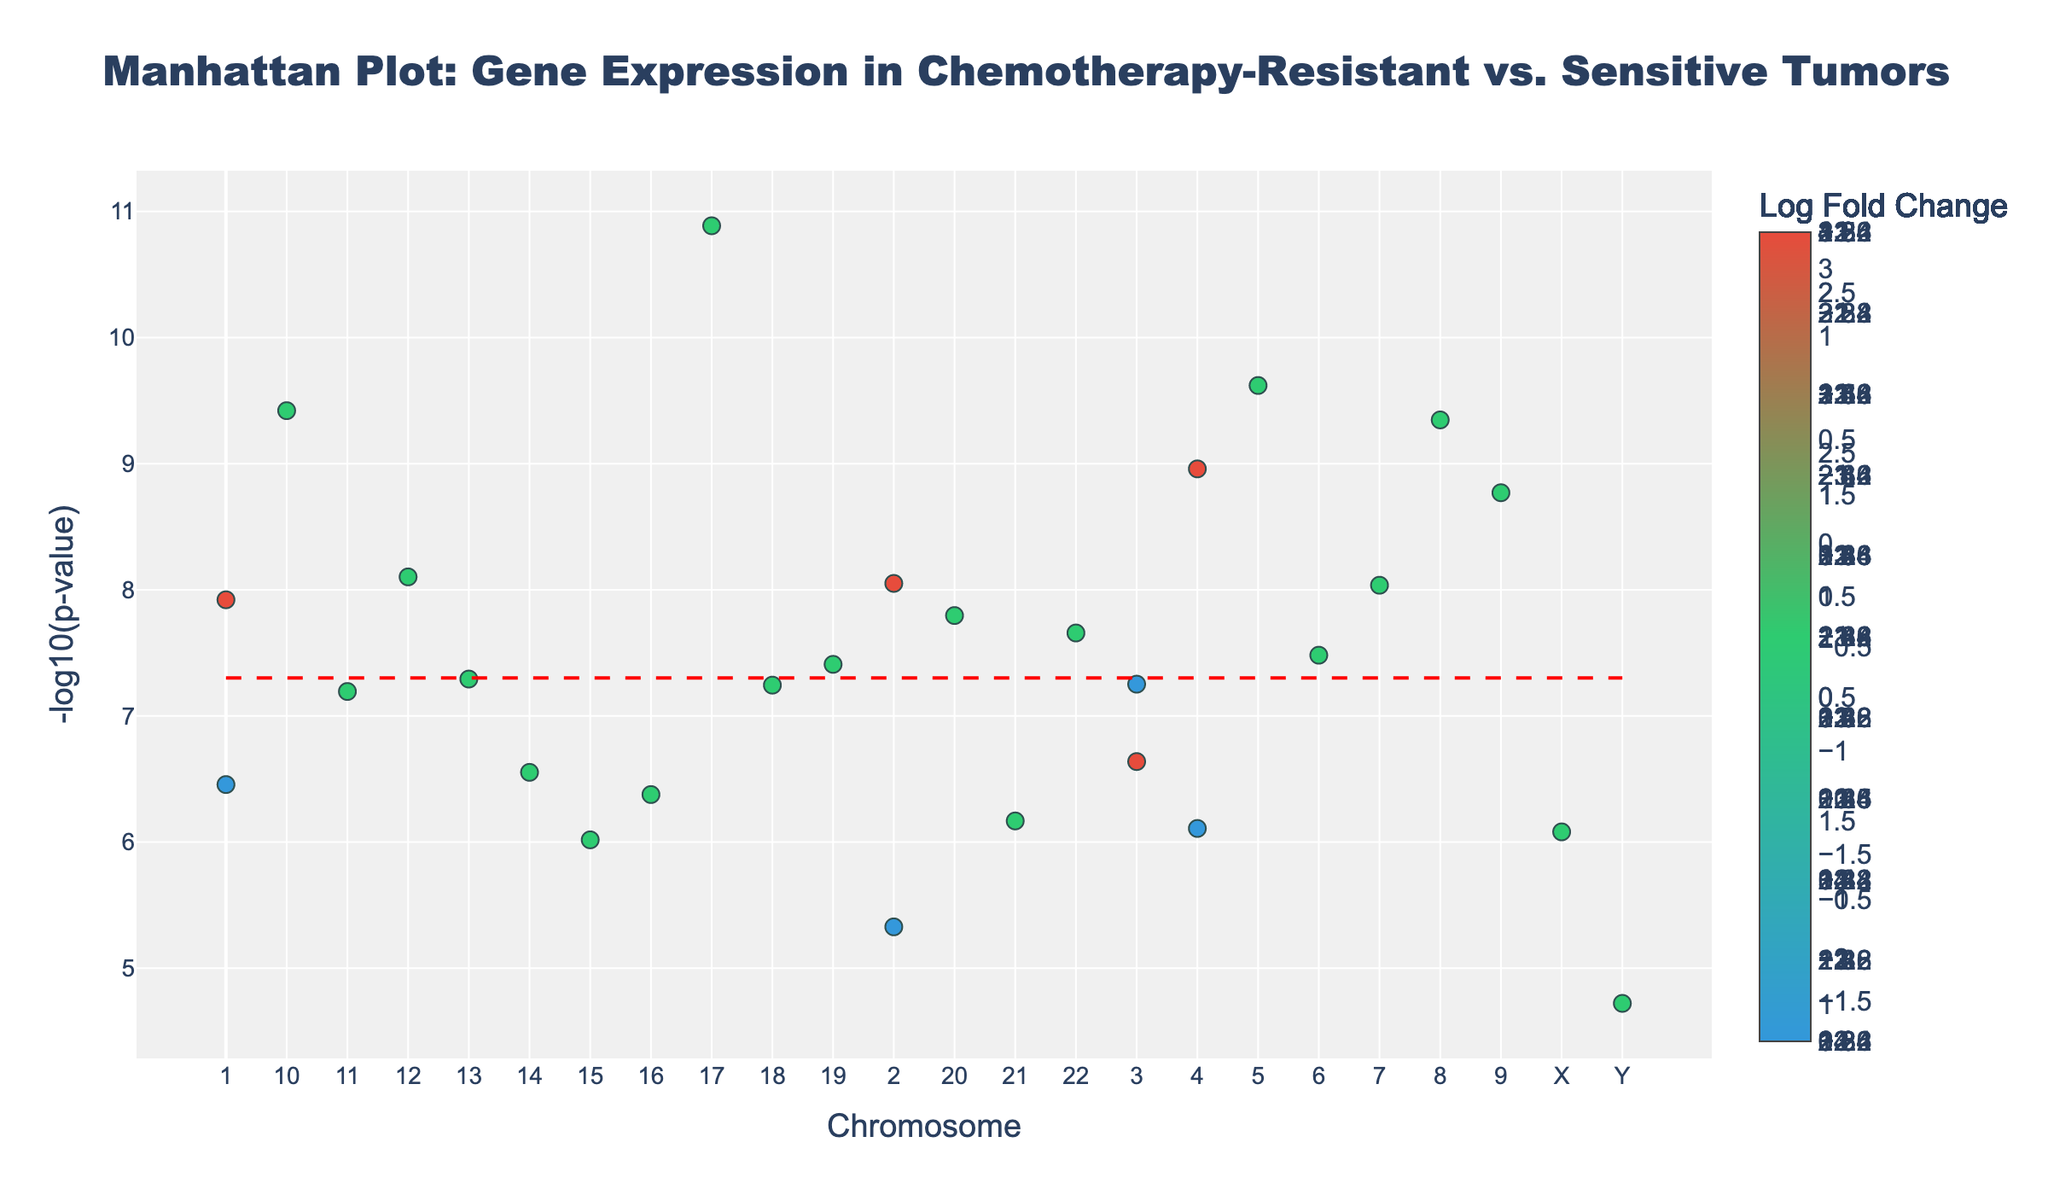What's the title of the figure? The title is usually at the top of the plot and provides the main context. In this case, it reads "Manhattan Plot: Gene Expression in Chemotherapy-Resistant vs. Sensitive Tumors".
Answer: Manhattan Plot: Gene Expression in Chemotherapy-Resistant vs. Sensitive Tumors How many chromosomes are represented in the plot? The x-axis shows the chromosomes labeled 1 through 22, plus X and Y. Counting these provides the total number of chromosomes represented.
Answer: 24 Which gene has the smallest p-value and how is it identified visually? To find the smallest p-value, look for the highest point (greatest negative logarithm) on the plot. The gene with the highest point is TP53, which has the highest -log10(p-value) value.
Answer: TP53 Which chromosomes have more than one gene plotted? By observing the plot, identify chromosomes with more than one distinct data point. Chromosomes 1, 2, 3, 4, 8, 10, and 22 have multiple genes represented.
Answer: 1, 2, 3, 4, 8, 10, 22 How many genes exceed the significance threshold, indicated by the red dashed line? Count the points above the red dashed line, which represents the significance level (-log10(5e-8)). There are 12 such points.
Answer: 12 Which genes have a LogFoldChange greater than 3? Examine the color scale to find genes with a LogFoldChange greater than 3. Based on the color, TERT and MYC on Chromosome 8 meet this criterion.
Answer: TERT, MYC For which chromosome is the gene labeled with the highest positive LogFoldChange, and how is this observed? Identify the chromosome with the highest positive LogFoldChange by finding the brightest color corresponding to the highest LogFoldChange value. The gene TERT on Chromosome 5 has the highest positive LogFoldChange.
Answer: Chromosome 5 Compare the -log10(p-value) of the genes MYC on chromosomes 2 and 8. Which one is higher? Locate the points corresponding to MYC on Chromosomes 2 and 8, then compare their positions on the y-axis (-log10(p-value)). The MYC gene on Chromosome 8 is positioned higher, indicating a higher significance.
Answer: Chromosome 8 What is the general trend observed for the LogFoldChange in chemotherapy-resistant vs. sensitive tumors across the genome? By examining the color scale and distribution of colors across the plot, observe whether there's a predominant trend in positive or negative LogFoldChanges across chromosomes. There is a general mix of both positive and negative LogFoldChanges, but genes with a higher LogFoldChange are often more significant.
Answer: Mixed trend Which gene on Chromosome 10 has a notable influence in chemotherapy resistance due to significant gene expression changes? By looking at Chromosome 10, find the only notable point, which is PTEN with a significant -log10(p-value) and a high negative LogFoldChange indicating its role in resistance.
Answer: PTEN 